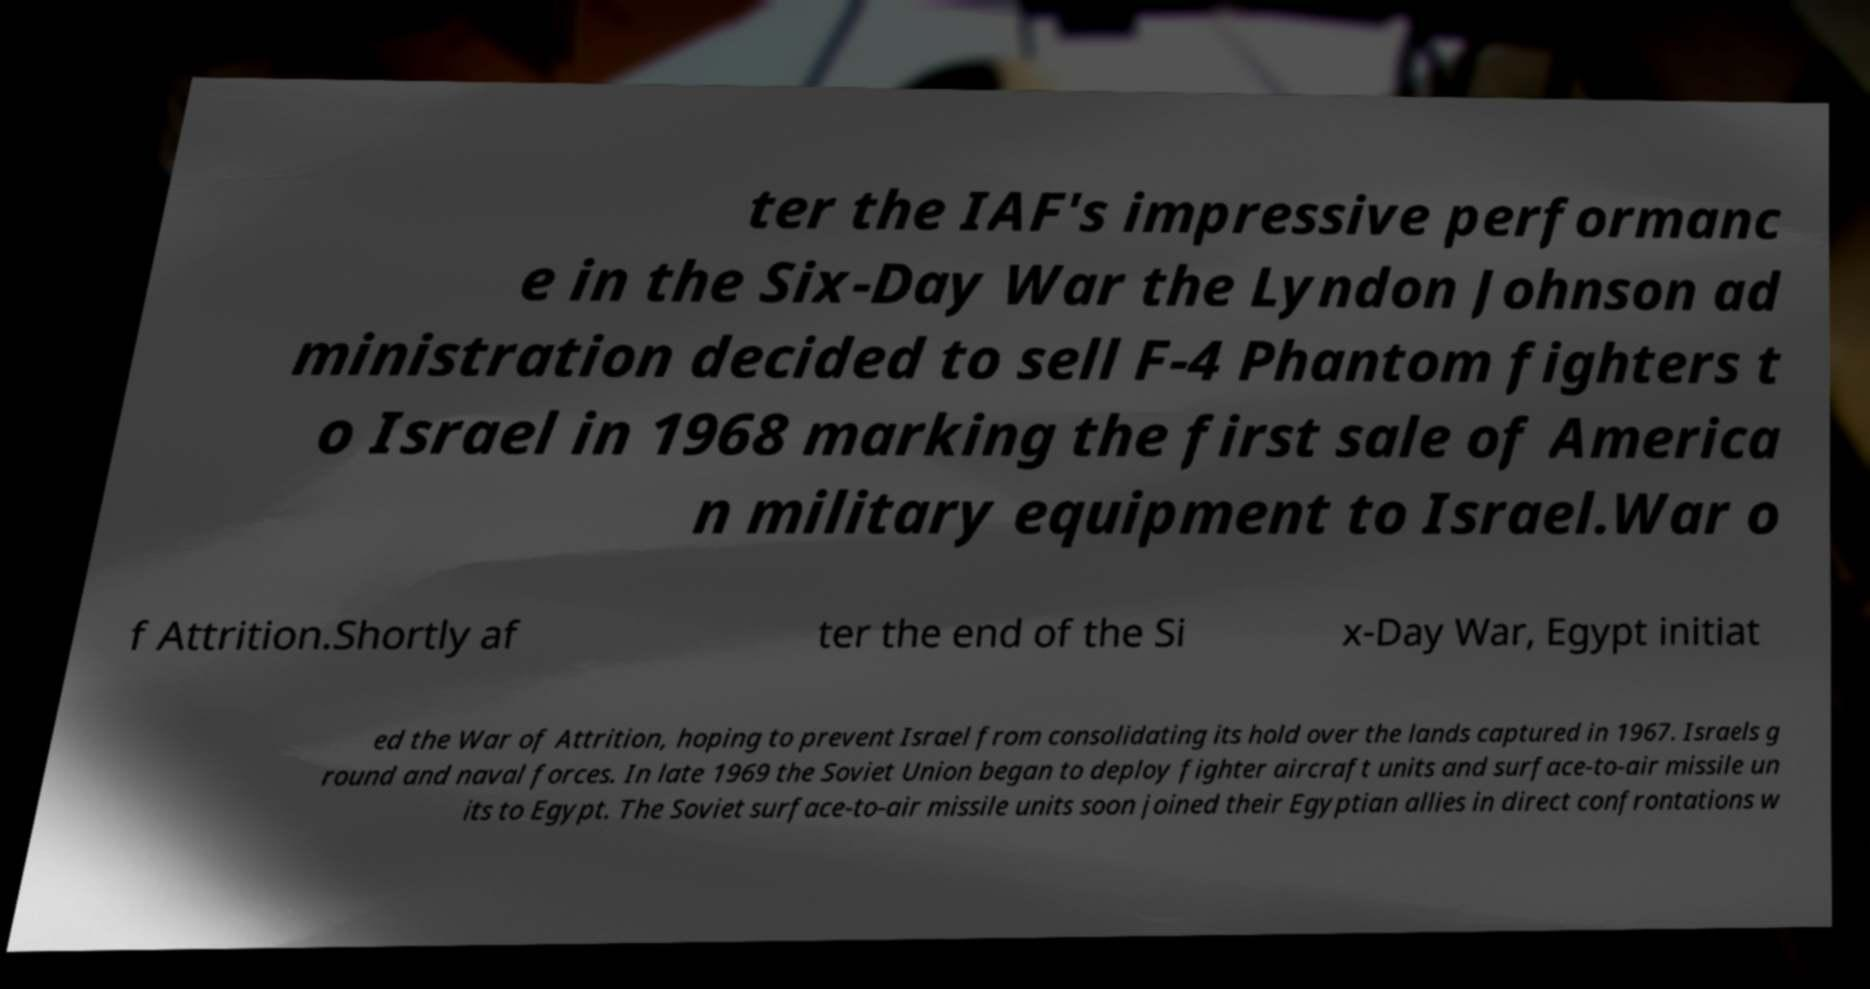Can you accurately transcribe the text from the provided image for me? ter the IAF's impressive performanc e in the Six-Day War the Lyndon Johnson ad ministration decided to sell F-4 Phantom fighters t o Israel in 1968 marking the first sale of America n military equipment to Israel.War o f Attrition.Shortly af ter the end of the Si x-Day War, Egypt initiat ed the War of Attrition, hoping to prevent Israel from consolidating its hold over the lands captured in 1967. Israels g round and naval forces. In late 1969 the Soviet Union began to deploy fighter aircraft units and surface-to-air missile un its to Egypt. The Soviet surface-to-air missile units soon joined their Egyptian allies in direct confrontations w 